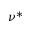<formula> <loc_0><loc_0><loc_500><loc_500>\nu ^ { * }</formula> 